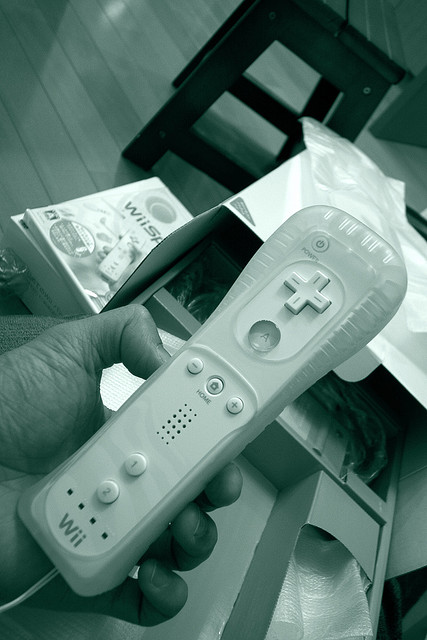Please transcribe the text in this image. HOME wiiSp Wii 